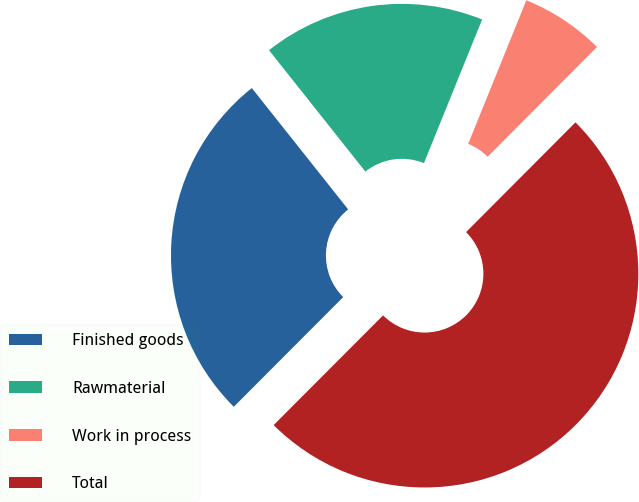Convert chart. <chart><loc_0><loc_0><loc_500><loc_500><pie_chart><fcel>Finished goods<fcel>Rawmaterial<fcel>Work in process<fcel>Total<nl><fcel>26.84%<fcel>16.8%<fcel>6.35%<fcel>50.0%<nl></chart> 